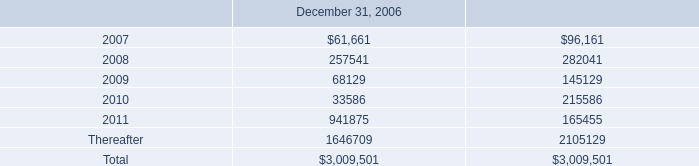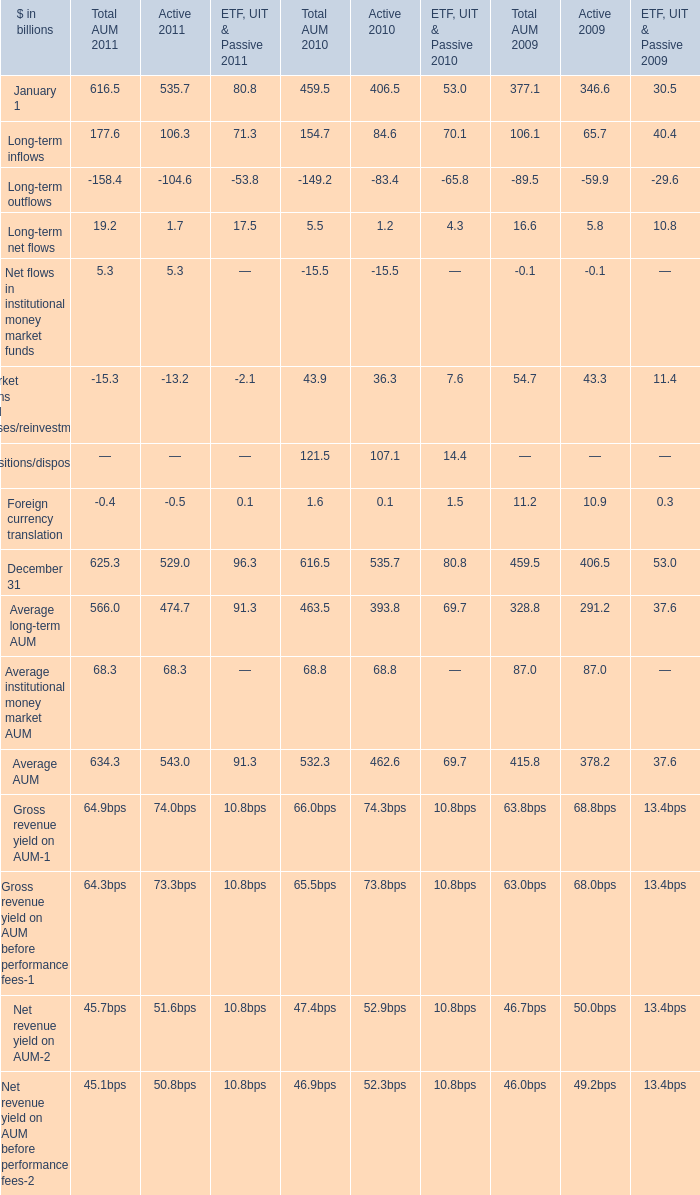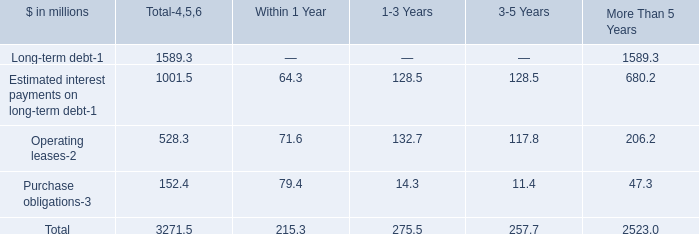what is the yearly interest expense associated with the certegy merger , ( in millions ) ? 
Computations: (200 * 4.75%)
Answer: 9.5. 